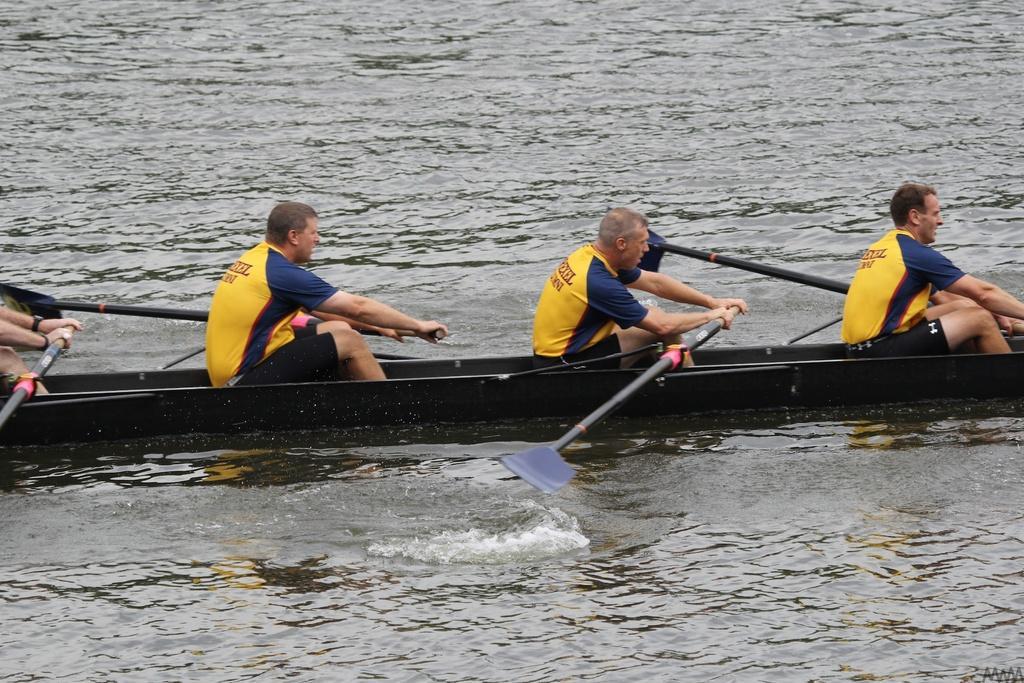In one or two sentences, can you explain what this image depicts? In the center of the image there are people sitting in boat. At the bottom of the image there is water. 